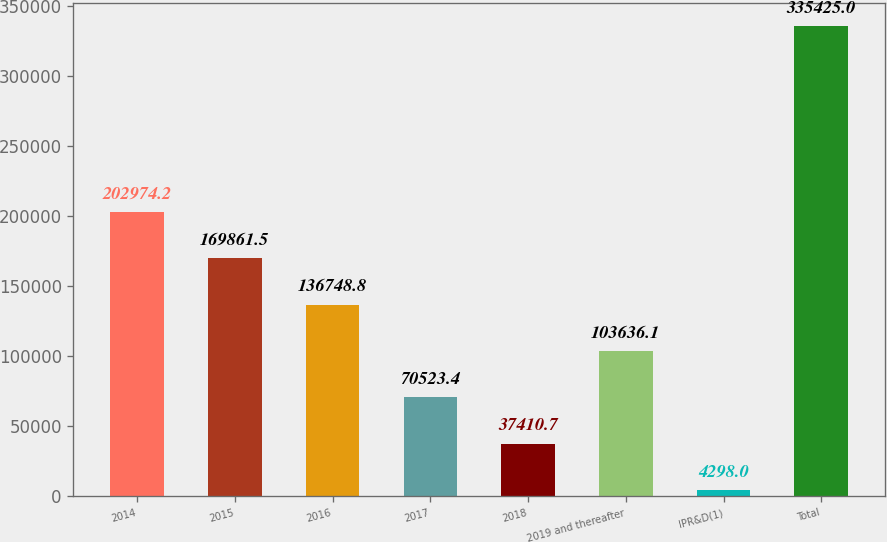Convert chart. <chart><loc_0><loc_0><loc_500><loc_500><bar_chart><fcel>2014<fcel>2015<fcel>2016<fcel>2017<fcel>2018<fcel>2019 and thereafter<fcel>IPR&D(1)<fcel>Total<nl><fcel>202974<fcel>169862<fcel>136749<fcel>70523.4<fcel>37410.7<fcel>103636<fcel>4298<fcel>335425<nl></chart> 